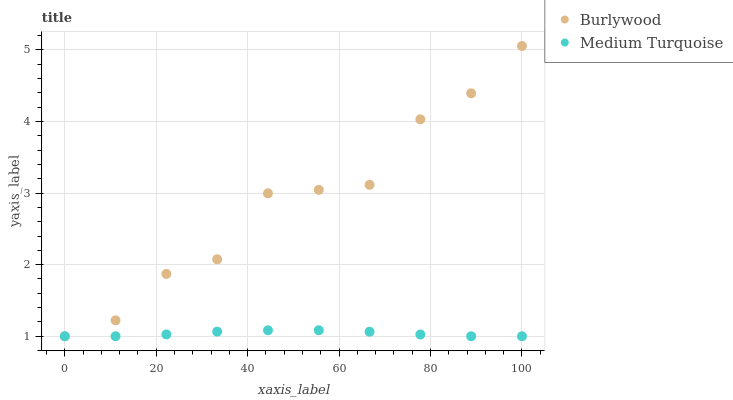Does Medium Turquoise have the minimum area under the curve?
Answer yes or no. Yes. Does Burlywood have the maximum area under the curve?
Answer yes or no. Yes. Does Medium Turquoise have the maximum area under the curve?
Answer yes or no. No. Is Medium Turquoise the smoothest?
Answer yes or no. Yes. Is Burlywood the roughest?
Answer yes or no. Yes. Is Medium Turquoise the roughest?
Answer yes or no. No. Does Burlywood have the lowest value?
Answer yes or no. Yes. Does Burlywood have the highest value?
Answer yes or no. Yes. Does Medium Turquoise have the highest value?
Answer yes or no. No. Does Medium Turquoise intersect Burlywood?
Answer yes or no. Yes. Is Medium Turquoise less than Burlywood?
Answer yes or no. No. Is Medium Turquoise greater than Burlywood?
Answer yes or no. No. 